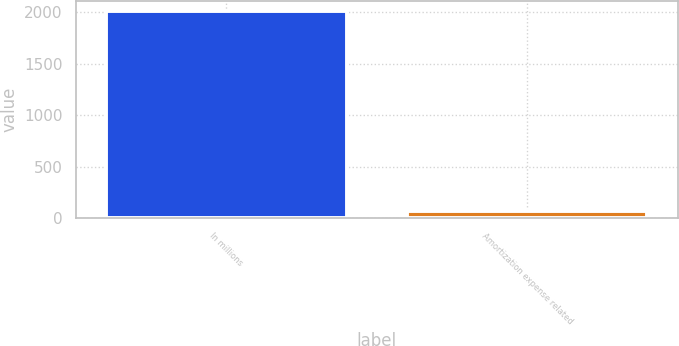<chart> <loc_0><loc_0><loc_500><loc_500><bar_chart><fcel>In millions<fcel>Amortization expense related<nl><fcel>2014<fcel>73<nl></chart> 